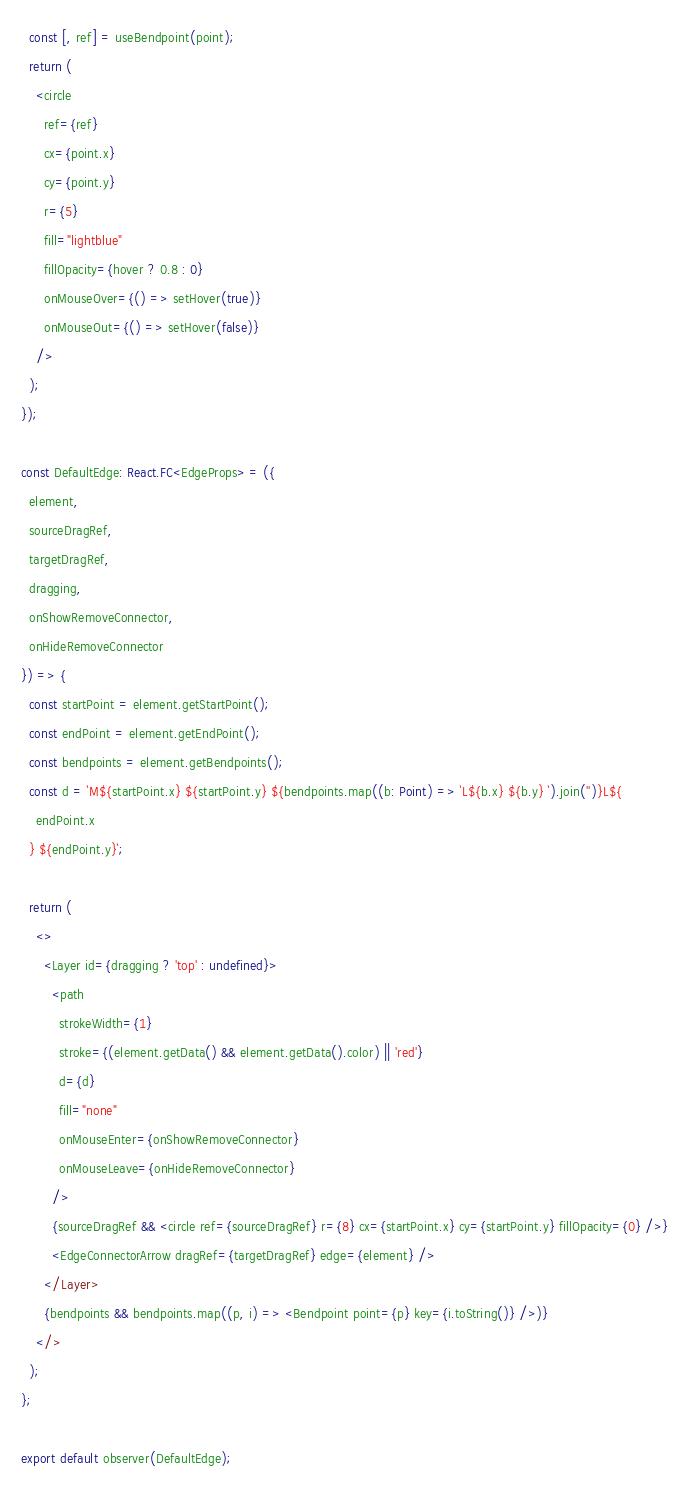Convert code to text. <code><loc_0><loc_0><loc_500><loc_500><_TypeScript_>  const [, ref] = useBendpoint(point);
  return (
    <circle
      ref={ref}
      cx={point.x}
      cy={point.y}
      r={5}
      fill="lightblue"
      fillOpacity={hover ? 0.8 : 0}
      onMouseOver={() => setHover(true)}
      onMouseOut={() => setHover(false)}
    />
  );
});

const DefaultEdge: React.FC<EdgeProps> = ({
  element,
  sourceDragRef,
  targetDragRef,
  dragging,
  onShowRemoveConnector,
  onHideRemoveConnector
}) => {
  const startPoint = element.getStartPoint();
  const endPoint = element.getEndPoint();
  const bendpoints = element.getBendpoints();
  const d = `M${startPoint.x} ${startPoint.y} ${bendpoints.map((b: Point) => `L${b.x} ${b.y} `).join('')}L${
    endPoint.x
  } ${endPoint.y}`;

  return (
    <>
      <Layer id={dragging ? 'top' : undefined}>
        <path
          strokeWidth={1}
          stroke={(element.getData() && element.getData().color) || 'red'}
          d={d}
          fill="none"
          onMouseEnter={onShowRemoveConnector}
          onMouseLeave={onHideRemoveConnector}
        />
        {sourceDragRef && <circle ref={sourceDragRef} r={8} cx={startPoint.x} cy={startPoint.y} fillOpacity={0} />}
        <EdgeConnectorArrow dragRef={targetDragRef} edge={element} />
      </Layer>
      {bendpoints && bendpoints.map((p, i) => <Bendpoint point={p} key={i.toString()} />)}
    </>
  );
};

export default observer(DefaultEdge);
</code> 